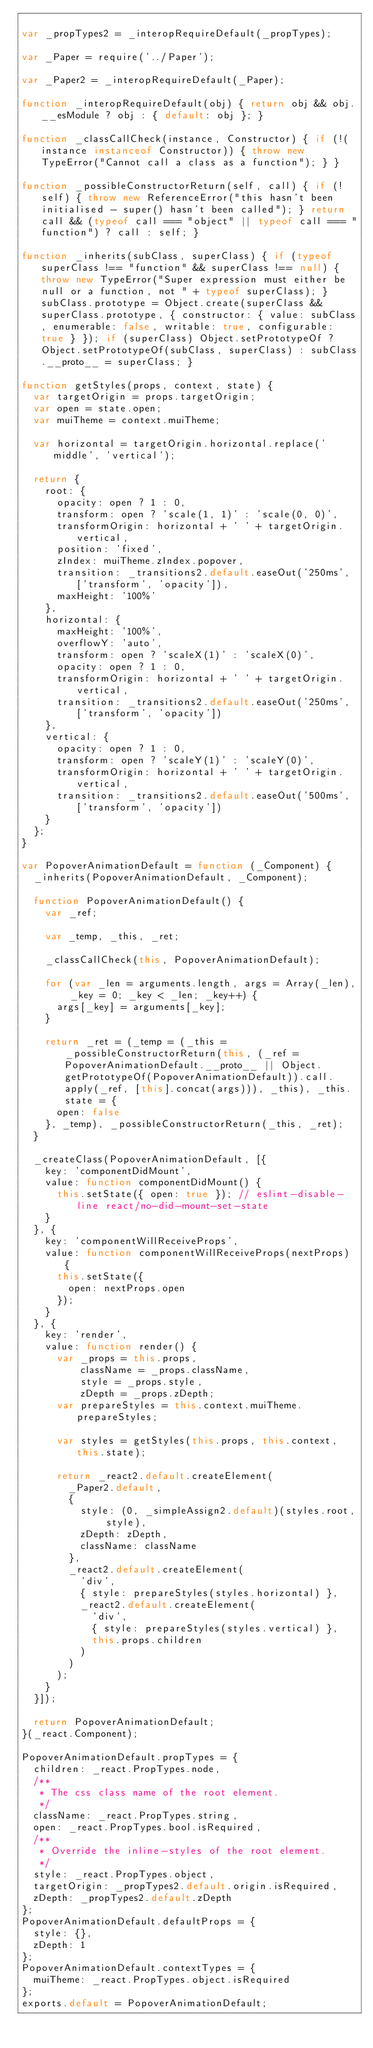Convert code to text. <code><loc_0><loc_0><loc_500><loc_500><_JavaScript_>
var _propTypes2 = _interopRequireDefault(_propTypes);

var _Paper = require('../Paper');

var _Paper2 = _interopRequireDefault(_Paper);

function _interopRequireDefault(obj) { return obj && obj.__esModule ? obj : { default: obj }; }

function _classCallCheck(instance, Constructor) { if (!(instance instanceof Constructor)) { throw new TypeError("Cannot call a class as a function"); } }

function _possibleConstructorReturn(self, call) { if (!self) { throw new ReferenceError("this hasn't been initialised - super() hasn't been called"); } return call && (typeof call === "object" || typeof call === "function") ? call : self; }

function _inherits(subClass, superClass) { if (typeof superClass !== "function" && superClass !== null) { throw new TypeError("Super expression must either be null or a function, not " + typeof superClass); } subClass.prototype = Object.create(superClass && superClass.prototype, { constructor: { value: subClass, enumerable: false, writable: true, configurable: true } }); if (superClass) Object.setPrototypeOf ? Object.setPrototypeOf(subClass, superClass) : subClass.__proto__ = superClass; }

function getStyles(props, context, state) {
  var targetOrigin = props.targetOrigin;
  var open = state.open;
  var muiTheme = context.muiTheme;

  var horizontal = targetOrigin.horizontal.replace('middle', 'vertical');

  return {
    root: {
      opacity: open ? 1 : 0,
      transform: open ? 'scale(1, 1)' : 'scale(0, 0)',
      transformOrigin: horizontal + ' ' + targetOrigin.vertical,
      position: 'fixed',
      zIndex: muiTheme.zIndex.popover,
      transition: _transitions2.default.easeOut('250ms', ['transform', 'opacity']),
      maxHeight: '100%'
    },
    horizontal: {
      maxHeight: '100%',
      overflowY: 'auto',
      transform: open ? 'scaleX(1)' : 'scaleX(0)',
      opacity: open ? 1 : 0,
      transformOrigin: horizontal + ' ' + targetOrigin.vertical,
      transition: _transitions2.default.easeOut('250ms', ['transform', 'opacity'])
    },
    vertical: {
      opacity: open ? 1 : 0,
      transform: open ? 'scaleY(1)' : 'scaleY(0)',
      transformOrigin: horizontal + ' ' + targetOrigin.vertical,
      transition: _transitions2.default.easeOut('500ms', ['transform', 'opacity'])
    }
  };
}

var PopoverAnimationDefault = function (_Component) {
  _inherits(PopoverAnimationDefault, _Component);

  function PopoverAnimationDefault() {
    var _ref;

    var _temp, _this, _ret;

    _classCallCheck(this, PopoverAnimationDefault);

    for (var _len = arguments.length, args = Array(_len), _key = 0; _key < _len; _key++) {
      args[_key] = arguments[_key];
    }

    return _ret = (_temp = (_this = _possibleConstructorReturn(this, (_ref = PopoverAnimationDefault.__proto__ || Object.getPrototypeOf(PopoverAnimationDefault)).call.apply(_ref, [this].concat(args))), _this), _this.state = {
      open: false
    }, _temp), _possibleConstructorReturn(_this, _ret);
  }

  _createClass(PopoverAnimationDefault, [{
    key: 'componentDidMount',
    value: function componentDidMount() {
      this.setState({ open: true }); // eslint-disable-line react/no-did-mount-set-state
    }
  }, {
    key: 'componentWillReceiveProps',
    value: function componentWillReceiveProps(nextProps) {
      this.setState({
        open: nextProps.open
      });
    }
  }, {
    key: 'render',
    value: function render() {
      var _props = this.props,
          className = _props.className,
          style = _props.style,
          zDepth = _props.zDepth;
      var prepareStyles = this.context.muiTheme.prepareStyles;

      var styles = getStyles(this.props, this.context, this.state);

      return _react2.default.createElement(
        _Paper2.default,
        {
          style: (0, _simpleAssign2.default)(styles.root, style),
          zDepth: zDepth,
          className: className
        },
        _react2.default.createElement(
          'div',
          { style: prepareStyles(styles.horizontal) },
          _react2.default.createElement(
            'div',
            { style: prepareStyles(styles.vertical) },
            this.props.children
          )
        )
      );
    }
  }]);

  return PopoverAnimationDefault;
}(_react.Component);

PopoverAnimationDefault.propTypes = {
  children: _react.PropTypes.node,
  /**
   * The css class name of the root element.
   */
  className: _react.PropTypes.string,
  open: _react.PropTypes.bool.isRequired,
  /**
   * Override the inline-styles of the root element.
   */
  style: _react.PropTypes.object,
  targetOrigin: _propTypes2.default.origin.isRequired,
  zDepth: _propTypes2.default.zDepth
};
PopoverAnimationDefault.defaultProps = {
  style: {},
  zDepth: 1
};
PopoverAnimationDefault.contextTypes = {
  muiTheme: _react.PropTypes.object.isRequired
};
exports.default = PopoverAnimationDefault;</code> 